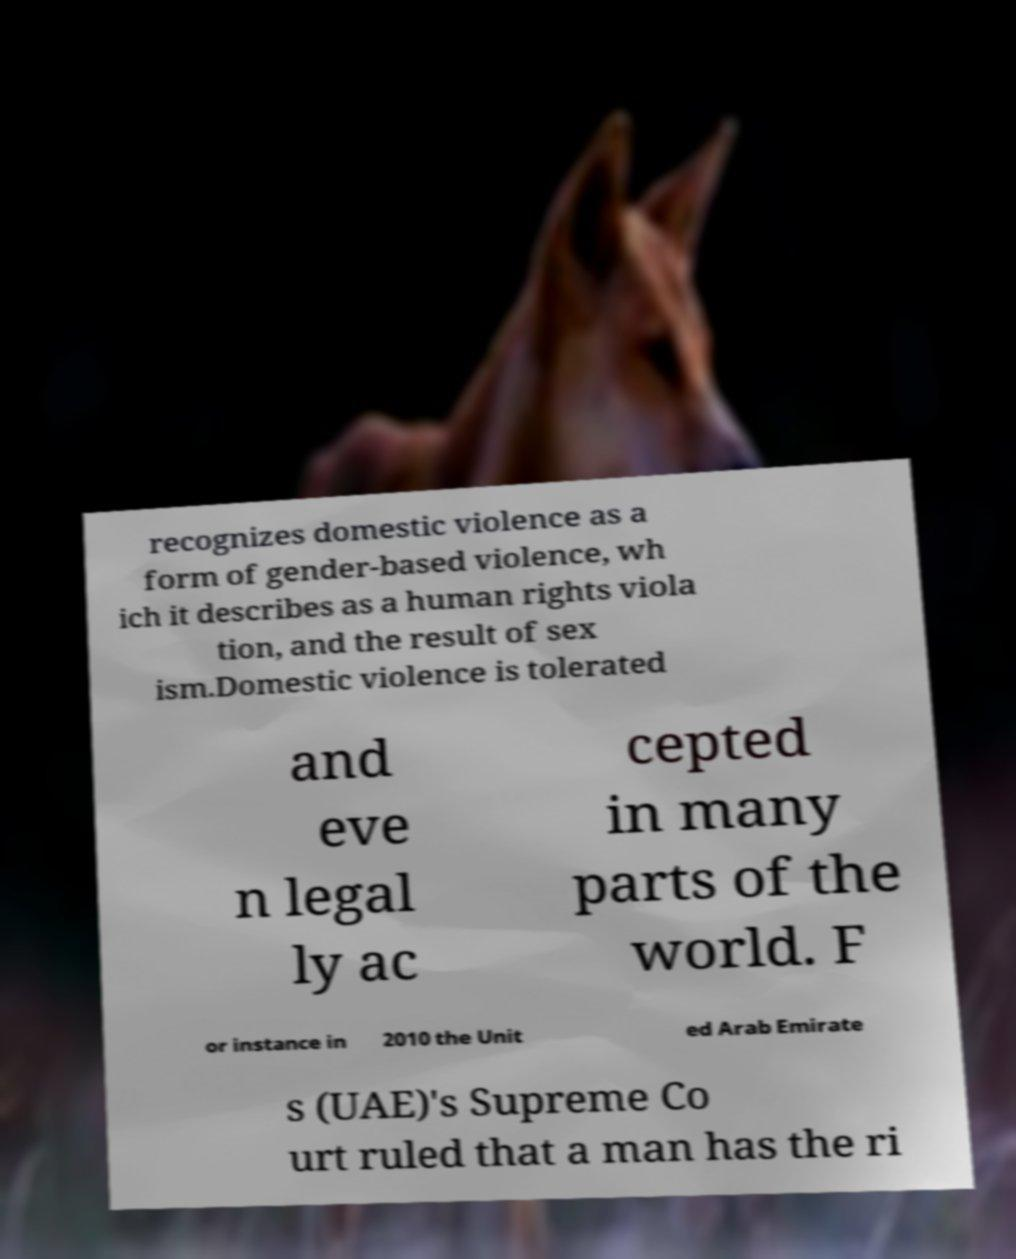Could you assist in decoding the text presented in this image and type it out clearly? recognizes domestic violence as a form of gender-based violence, wh ich it describes as a human rights viola tion, and the result of sex ism.Domestic violence is tolerated and eve n legal ly ac cepted in many parts of the world. F or instance in 2010 the Unit ed Arab Emirate s (UAE)'s Supreme Co urt ruled that a man has the ri 